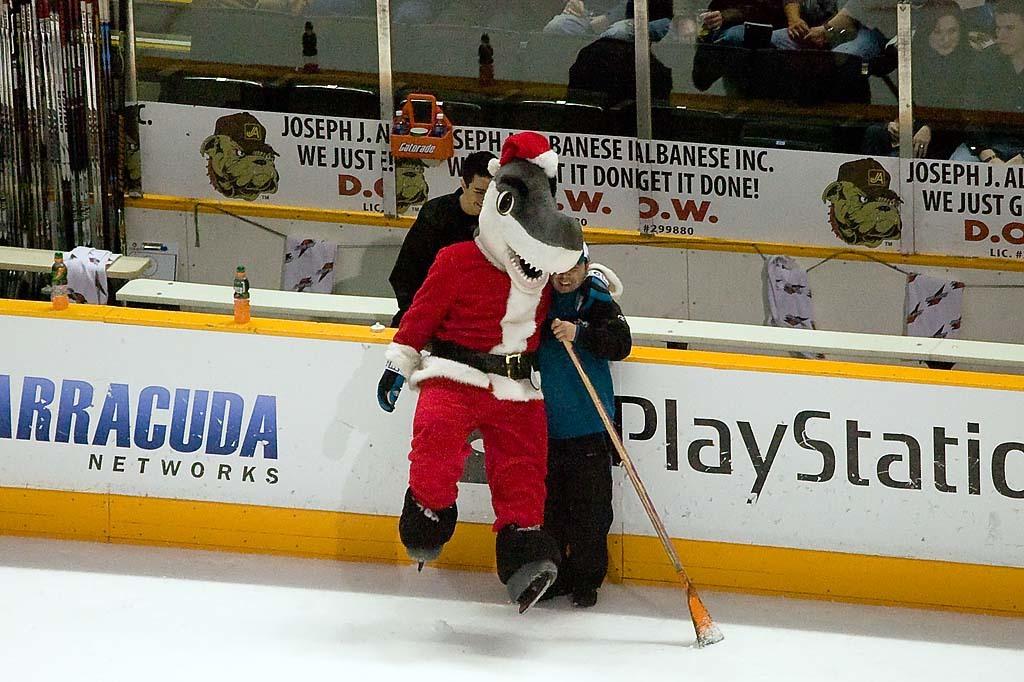What video game system is advertised here?
Offer a very short reply. Playstation. What network is it??
Provide a succinct answer. Barracuda. 